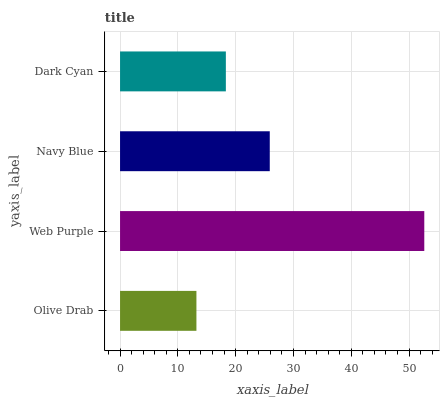Is Olive Drab the minimum?
Answer yes or no. Yes. Is Web Purple the maximum?
Answer yes or no. Yes. Is Navy Blue the minimum?
Answer yes or no. No. Is Navy Blue the maximum?
Answer yes or no. No. Is Web Purple greater than Navy Blue?
Answer yes or no. Yes. Is Navy Blue less than Web Purple?
Answer yes or no. Yes. Is Navy Blue greater than Web Purple?
Answer yes or no. No. Is Web Purple less than Navy Blue?
Answer yes or no. No. Is Navy Blue the high median?
Answer yes or no. Yes. Is Dark Cyan the low median?
Answer yes or no. Yes. Is Web Purple the high median?
Answer yes or no. No. Is Olive Drab the low median?
Answer yes or no. No. 